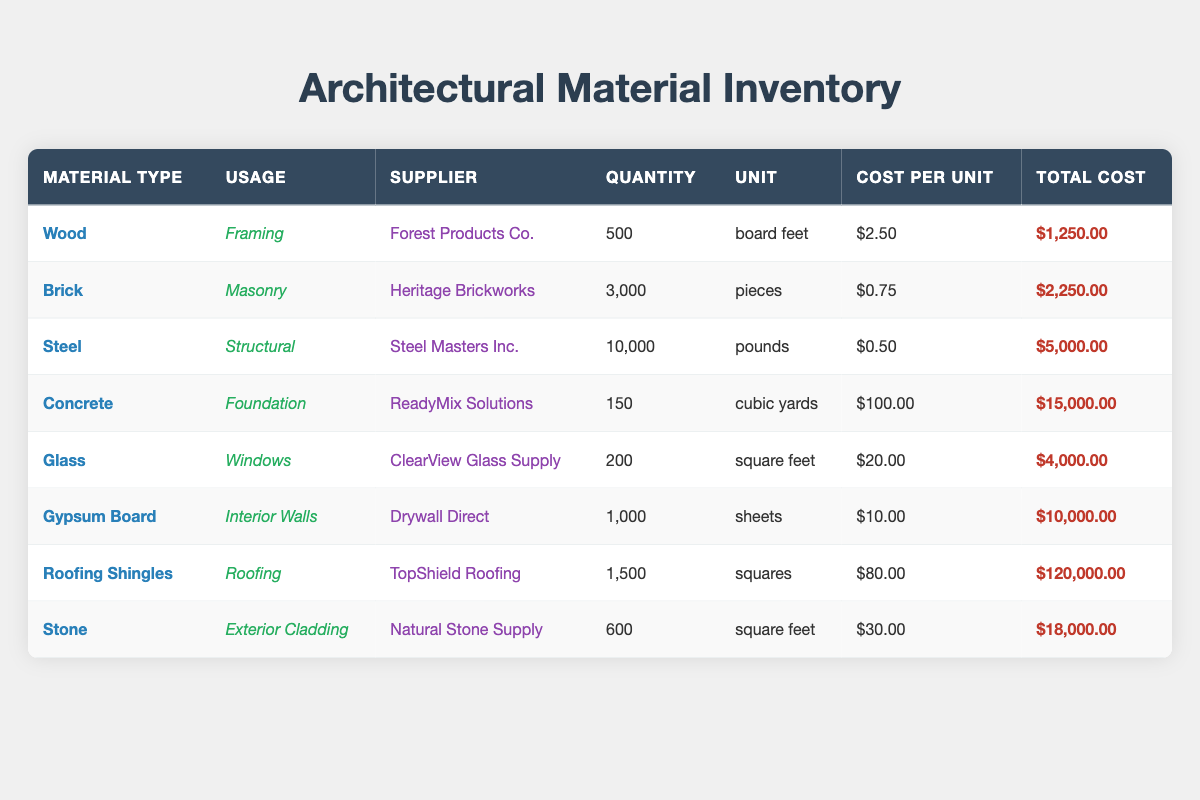What is the total cost of the Steel material? From the table, the total cost of Steel is listed as $5,000.00.
Answer: $5,000.00 Which material has the highest quantity in stock? The material with the highest quantity is Steel, with 10,000 pounds available.
Answer: Steel What is the average cost per unit of all materials? To find the average cost per unit, sum the total cost of all materials. The values are: (2.5 + 0.75 + 0.5 + 100 + 20 + 10 + 80 + 30) = 244.5. There are 8 materials, so the average cost per unit is 244.5 / 8 = 30.56.
Answer: 30.56 Is the total quantity of Brick greater than that of Glass? The quantity of Brick is 3,000 pieces, while the quantity of Glass is 200 square feet. Since 3,000 is greater than 200, the statement is true.
Answer: Yes What is the total cost of materials used for roofing (Roofing Shingles)? The table lists Roofing Shingles with a total cost of $120,000.00 specifically for roofing usage.
Answer: $120,000.00 How much more expensive is Concrete per unit compared to Brick? Concrete costs $100.00 per cubic yard, while Brick costs $0.75 per piece. The difference is 100.00 - 0.75 = 99.25. Therefore, Concrete is $99.25 more expensive per unit than Brick.
Answer: 99.25 What is the total quantity of materials used for foundations (Concrete) and framing (Wood) combined? The quantity for Concrete (foundation) is 150 cubic yards, and for Wood (framing) it is 500 board feet. The total quantity is 150 + 500 = 650.
Answer: 650 Is the supplier for Glass the same as for Wood? The supplier for Glass is ClearView Glass Supply, while the supplier for Wood is Forest Products Co. Therefore, they are different suppliers.
Answer: No What is the total number of materials listed in the inventory? There are 8 entries for materials in the inventory.
Answer: 8 